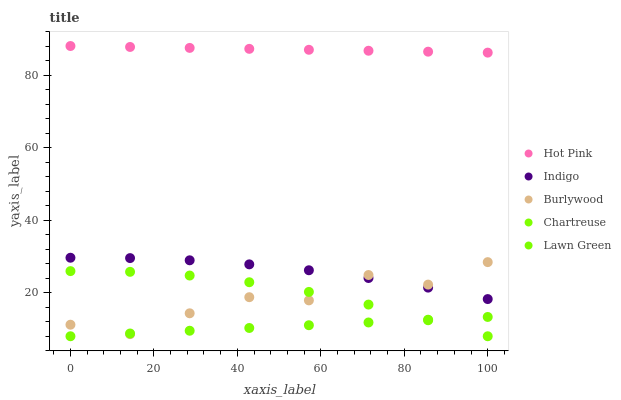Does Lawn Green have the minimum area under the curve?
Answer yes or no. Yes. Does Hot Pink have the maximum area under the curve?
Answer yes or no. Yes. Does Chartreuse have the minimum area under the curve?
Answer yes or no. No. Does Chartreuse have the maximum area under the curve?
Answer yes or no. No. Is Lawn Green the smoothest?
Answer yes or no. Yes. Is Burlywood the roughest?
Answer yes or no. Yes. Is Chartreuse the smoothest?
Answer yes or no. No. Is Chartreuse the roughest?
Answer yes or no. No. Does Lawn Green have the lowest value?
Answer yes or no. Yes. Does Hot Pink have the lowest value?
Answer yes or no. No. Does Hot Pink have the highest value?
Answer yes or no. Yes. Does Chartreuse have the highest value?
Answer yes or no. No. Is Burlywood less than Hot Pink?
Answer yes or no. Yes. Is Hot Pink greater than Indigo?
Answer yes or no. Yes. Does Lawn Green intersect Chartreuse?
Answer yes or no. Yes. Is Lawn Green less than Chartreuse?
Answer yes or no. No. Is Lawn Green greater than Chartreuse?
Answer yes or no. No. Does Burlywood intersect Hot Pink?
Answer yes or no. No. 